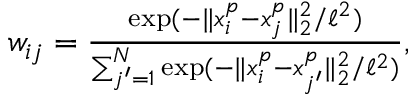<formula> <loc_0><loc_0><loc_500><loc_500>\begin{array} { r } { w _ { i j } = \frac { \exp ( - \| x _ { i } ^ { p } - x _ { j } ^ { p } \| _ { 2 } ^ { 2 } / \ell ^ { 2 } ) } { \sum _ { j ^ { \prime } = 1 } ^ { N } \exp ( - \| x _ { i } ^ { p } - x _ { j ^ { \prime } } ^ { p } \| _ { 2 } ^ { 2 } / \ell ^ { 2 } ) } , } \end{array}</formula> 